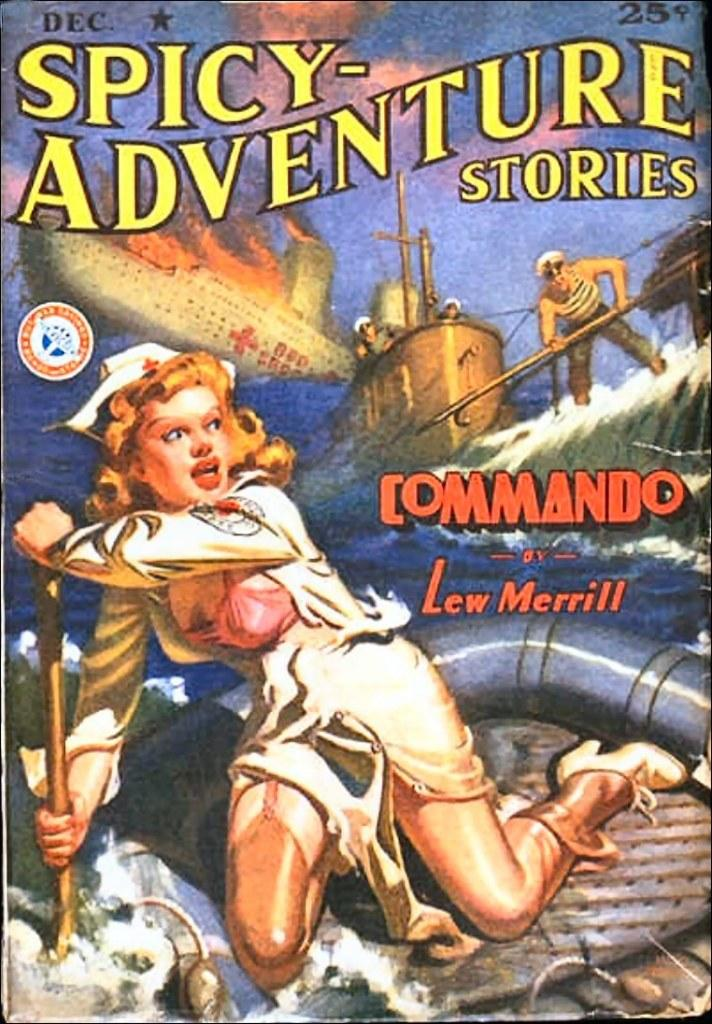<image>
Present a compact description of the photo's key features. a cover of the book spicy adventure stories written by Lew Merril. 